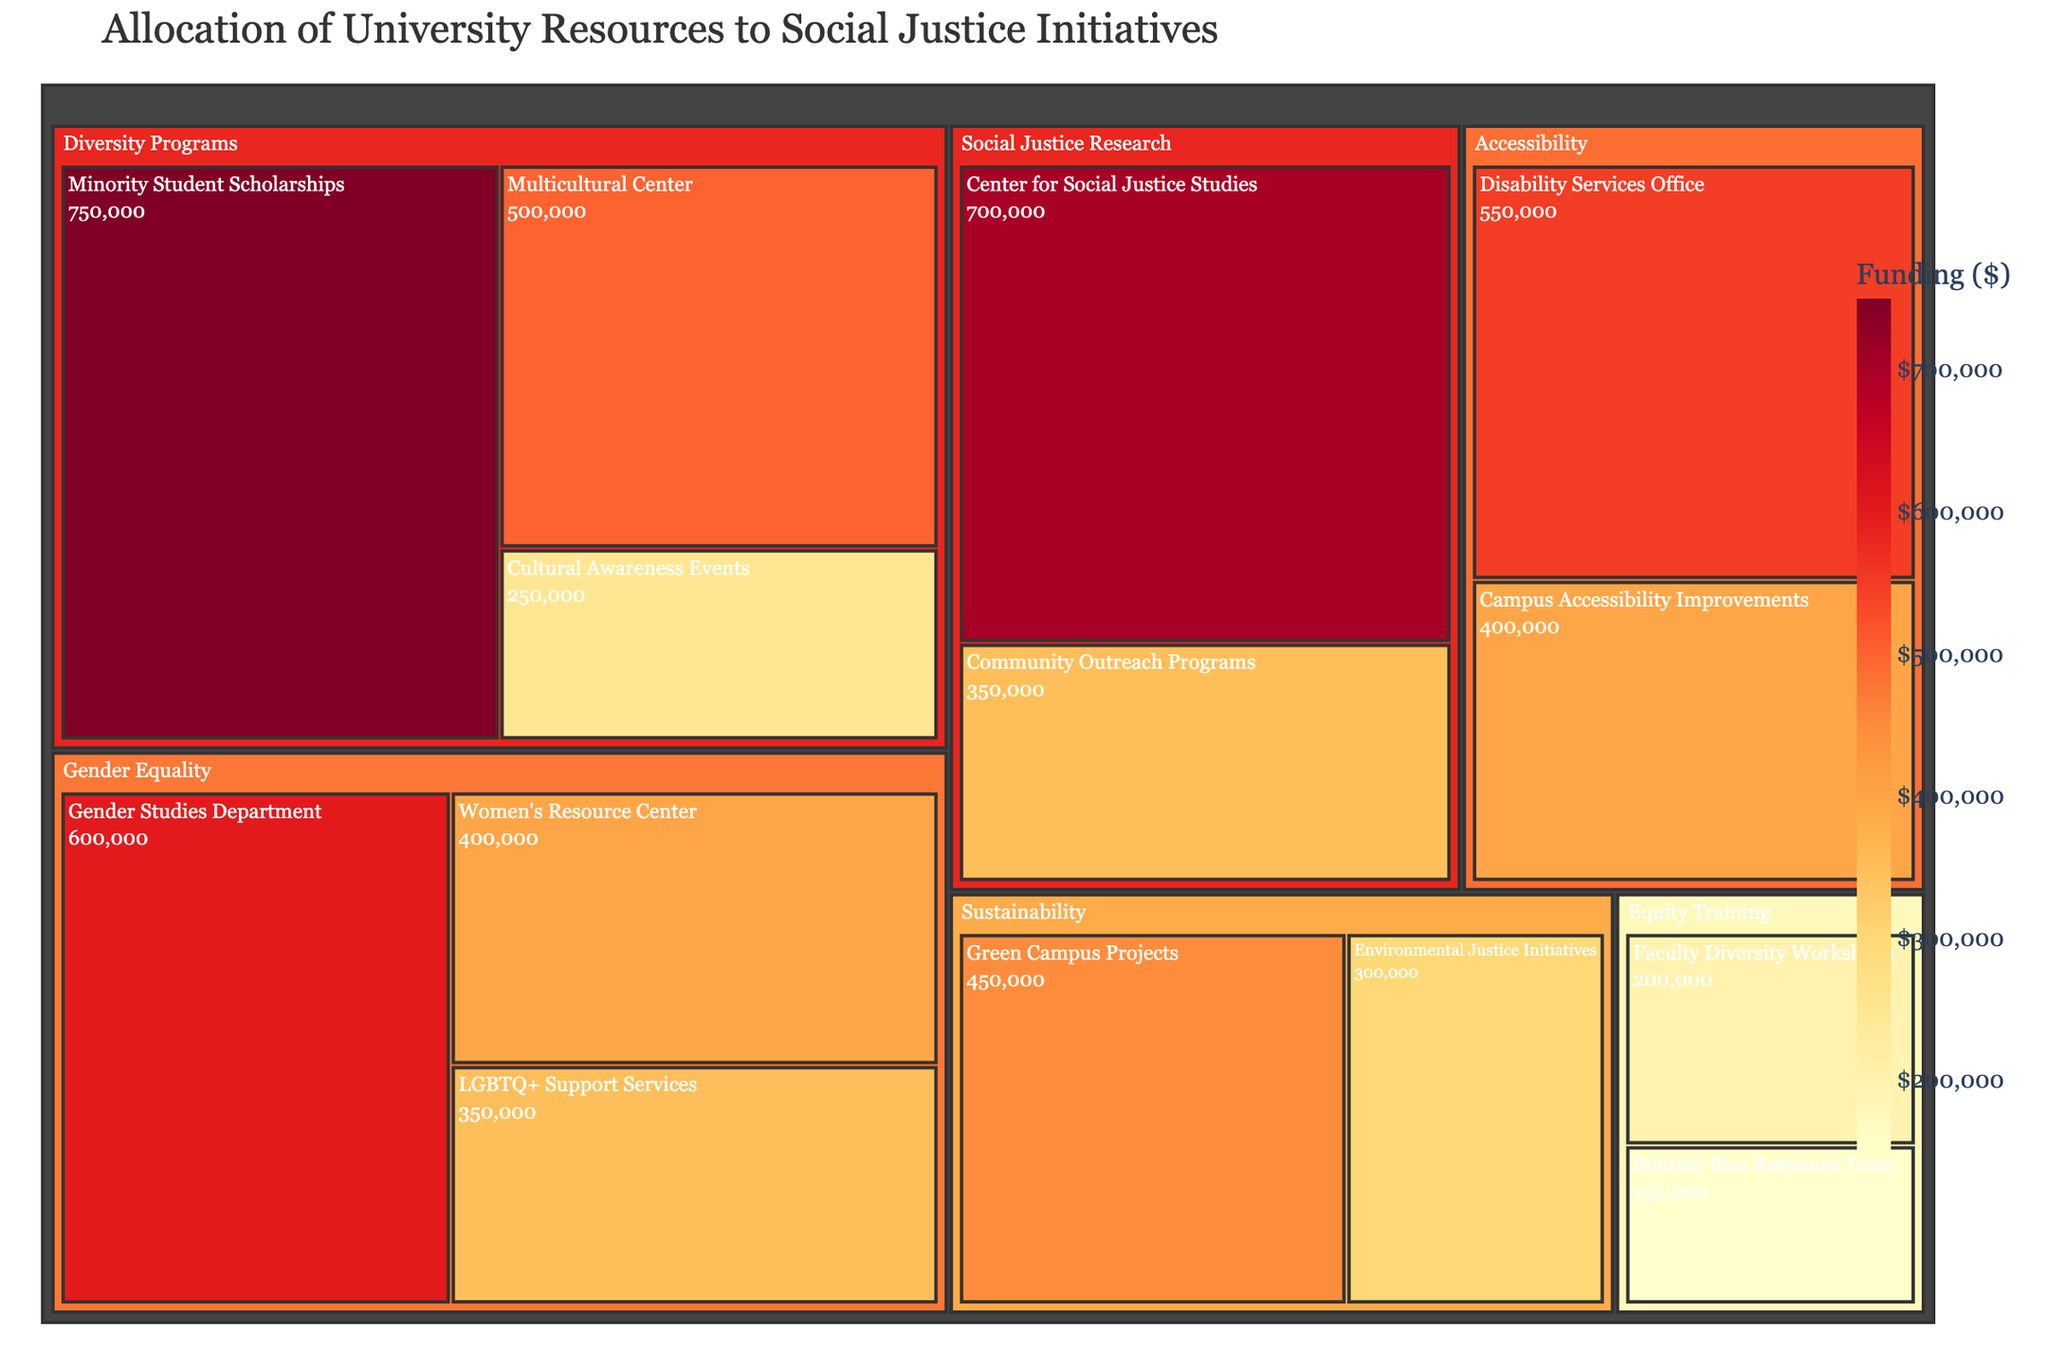What is the highest funded subcategory under Diversity Programs? Look at the size of the boxes within the Diversity Programs category and find the one with the largest value, which represents the highest funding.
Answer: Minority Student Scholarships Which category has the highest total funding allocated to it? Compare the total values of the different categories (Diversity Programs, Gender Equality, Sustainability, Accessibility, Social Justice Research, Equity Training). The category with the largest summed value will have the highest funding.
Answer: Diversity Programs What is the total funding allocated to Equity Training? Add the values of all subcategories under Equity Training (Faculty Diversity Workshops and Student Bias Response Team): 200000 + 150000.
Answer: 350000 How does the funding for the Women's Resource Center compare to that for the Disability Services Office? Compare the values for these two subcategories. The Women's Resource Center has 400,000 and the Disability Services Office has 550,000.
Answer: The Disability Services Office receives more funding What are the total funds allocated to Gender Equality initiatives? Add up the funding of all subcategories under Gender Equality: Women's Resource Center (400,000), LGBTQ+ Support Services (350,000), Gender Studies Department (600,000).
Answer: 1,350,000 Which subcategory under Social Justice Research has less funding, and by how much? Under the Social Justice Research category, compare the two subcategories: Center for Social Justice Studies (700,000) and Community Outreach Programs (350,000). Subtract the smaller value from the larger one.
Answer: Community Outreach Programs, by 350,000 What is the funding difference between the highest-funded and least-funded subcategories? Identify the highest-funded subcategory (Minority Student Scholarships with 750,000) and the least-funded subcategory (Student Bias Response Team with 150,000), then find the difference.
Answer: 600,000 What proportion of the total funds are allocated to Sustainability initiatives? Sum the values of subcategories under Sustainability (Environmental Justice Initiatives and Green Campus Projects) and divide by the total allocation to all initiatives.
Answer: (300,000 + 450,000) / Total Funds What is the percentage of the total funding allocated to Accessibility? Calculate the sum of subcategories under Accessibility (Disability Services Office with 550,000 and Campus Accessibility Improvements with 400,000) and divide by the total funding across all categories, then multiply by 100 to get the percentage.
Answer: Percentage = (550,000 + 400,000) / Total Funds × 100 How many subcategories have a funding allocation above 500,000? Scan all the subcategories and count the ones with a value above 500,000. Count subcategories: Minority Student Scholarships, Gender Studies Department, Disability Services Office, Center for Social Justice Studies.
Answer: 4 